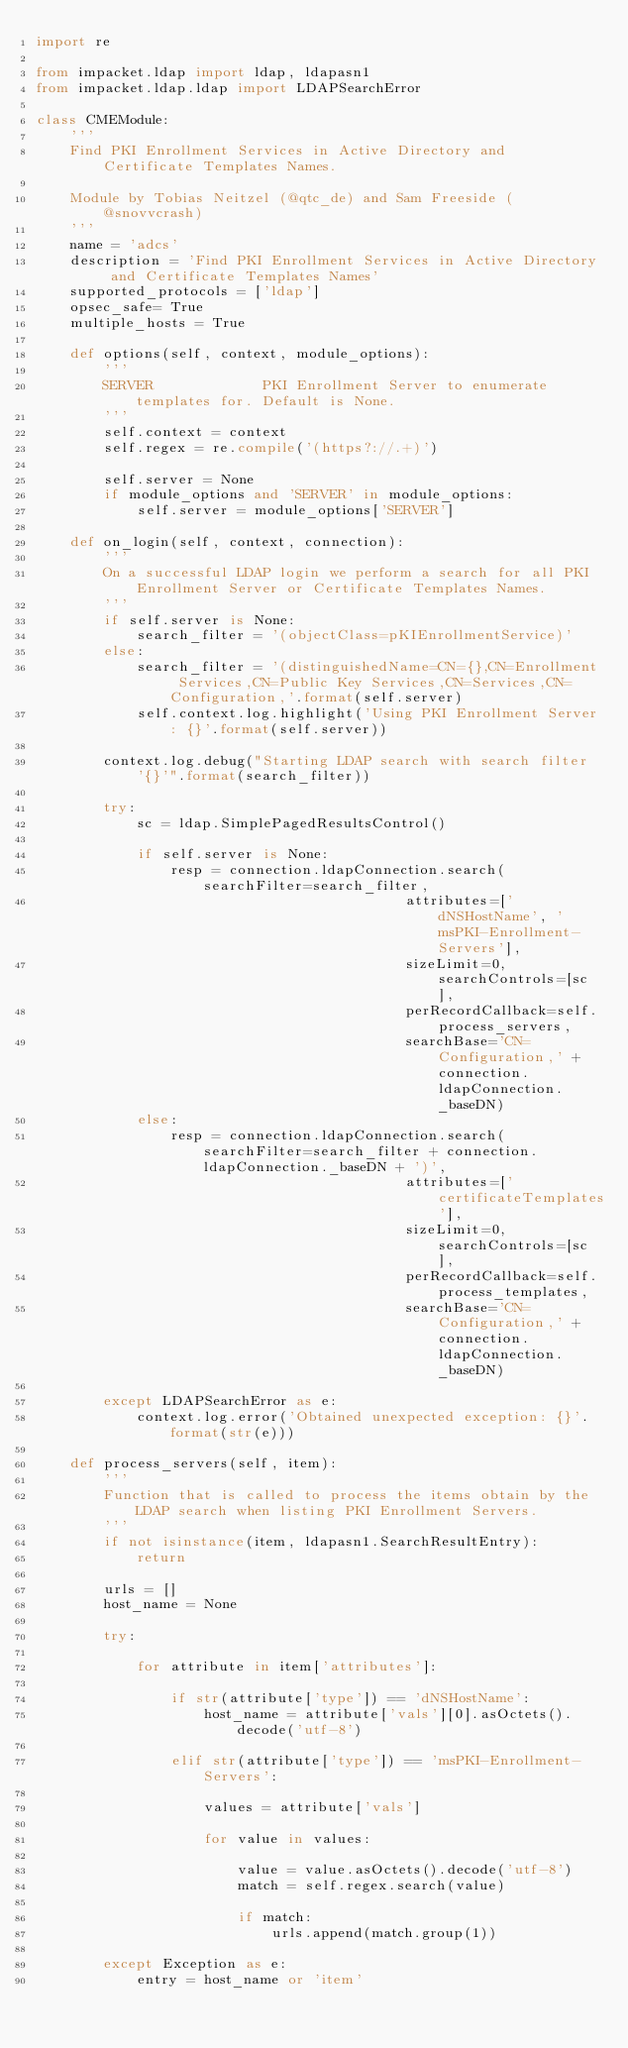<code> <loc_0><loc_0><loc_500><loc_500><_Python_>import re

from impacket.ldap import ldap, ldapasn1
from impacket.ldap.ldap import LDAPSearchError

class CMEModule:
    '''
    Find PKI Enrollment Services in Active Directory and Certificate Templates Names.

    Module by Tobias Neitzel (@qtc_de) and Sam Freeside (@snovvcrash)
    '''
    name = 'adcs'
    description = 'Find PKI Enrollment Services in Active Directory and Certificate Templates Names'
    supported_protocols = ['ldap']
    opsec_safe= True
    multiple_hosts = True

    def options(self, context, module_options):
        '''
        SERVER             PKI Enrollment Server to enumerate templates for. Default is None.
        '''
        self.context = context
        self.regex = re.compile('(https?://.+)')

        self.server = None
        if module_options and 'SERVER' in module_options:
            self.server = module_options['SERVER']

    def on_login(self, context, connection):
        '''
        On a successful LDAP login we perform a search for all PKI Enrollment Server or Certificate Templates Names.
        '''
        if self.server is None:
            search_filter = '(objectClass=pKIEnrollmentService)'
        else:
            search_filter = '(distinguishedName=CN={},CN=Enrollment Services,CN=Public Key Services,CN=Services,CN=Configuration,'.format(self.server)
            self.context.log.highlight('Using PKI Enrollment Server: {}'.format(self.server))

        context.log.debug("Starting LDAP search with search filter '{}'".format(search_filter))

        try:
            sc = ldap.SimplePagedResultsControl()

            if self.server is None:
                resp = connection.ldapConnection.search(searchFilter=search_filter,
                                            attributes=['dNSHostName', 'msPKI-Enrollment-Servers'],
                                            sizeLimit=0, searchControls=[sc],
                                            perRecordCallback=self.process_servers,
                                            searchBase='CN=Configuration,' + connection.ldapConnection._baseDN)
            else:
                resp = connection.ldapConnection.search(searchFilter=search_filter + connection.ldapConnection._baseDN + ')',
                                            attributes=['certificateTemplates'],
                                            sizeLimit=0, searchControls=[sc],
                                            perRecordCallback=self.process_templates,
                                            searchBase='CN=Configuration,' + connection.ldapConnection._baseDN)

        except LDAPSearchError as e:
            context.log.error('Obtained unexpected exception: {}'.format(str(e)))

    def process_servers(self, item):
        '''
        Function that is called to process the items obtain by the LDAP search when listing PKI Enrollment Servers.
        '''
        if not isinstance(item, ldapasn1.SearchResultEntry):
            return

        urls = []
        host_name = None

        try:

            for attribute in item['attributes']:

                if str(attribute['type']) == 'dNSHostName':
                    host_name = attribute['vals'][0].asOctets().decode('utf-8')

                elif str(attribute['type']) == 'msPKI-Enrollment-Servers':

                    values = attribute['vals']

                    for value in values:

                        value = value.asOctets().decode('utf-8')
                        match = self.regex.search(value)

                        if match:
                            urls.append(match.group(1))

        except Exception as e:
            entry = host_name or 'item'</code> 